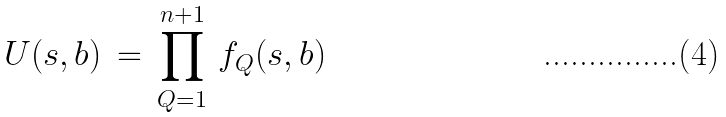<formula> <loc_0><loc_0><loc_500><loc_500>U ( s , b ) \, = \, \prod _ { Q = 1 } ^ { n + 1 } \, f _ { Q } ( s , b )</formula> 